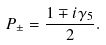<formula> <loc_0><loc_0><loc_500><loc_500>P _ { \pm } = \frac { 1 \mp i \gamma _ { 5 } } { 2 } .</formula> 